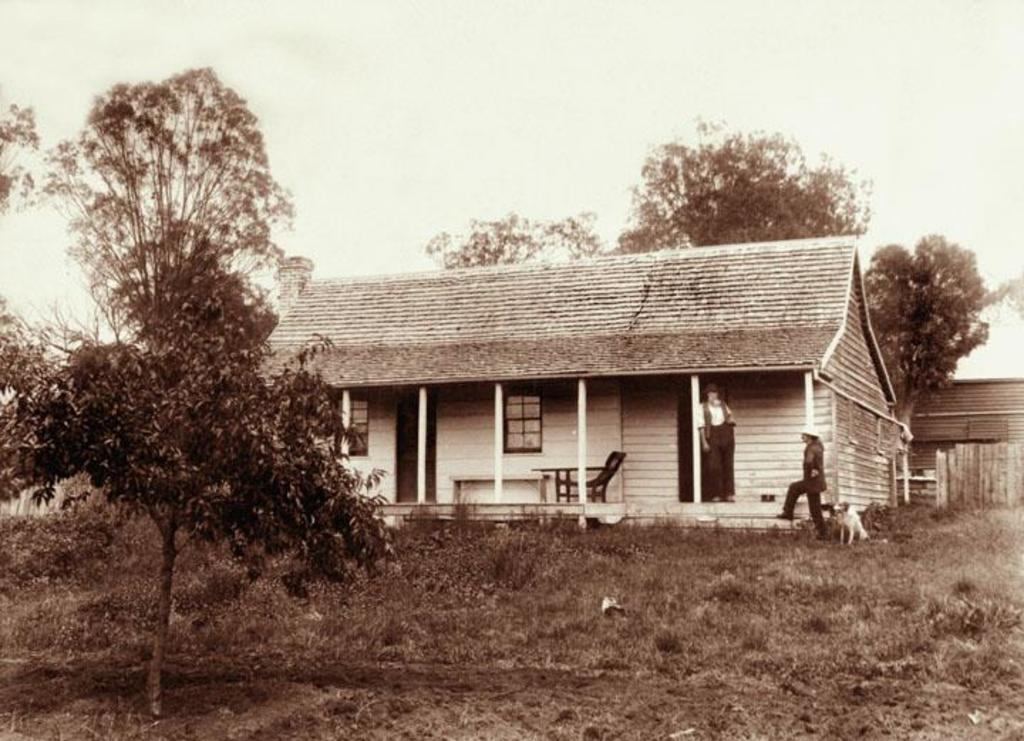What is the color scheme of the image? The image is black and white. What type of structure can be seen in the image? There is a building in the image. Are there any people present in the image? Yes, there are persons in the image. What type of furniture is visible in the image? There is a table and a chair in the image. What type of vegetation is present in the image? There is a tree and grass in the image. What can be seen in the background of the image? There are trees and the sky visible in the background of the image. Where is the stove located in the image? There is no stove present in the image. Can you tell me how many kitties are playing on the grass in the image? There are no kitties present in the image; it only features a tree and grass. 